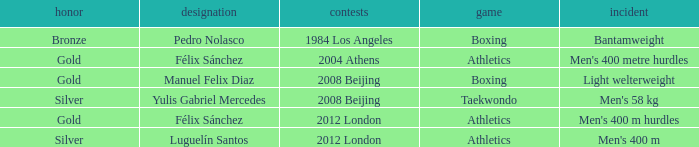Which Medal had a Games of 2008 beijing, and a Sport of taekwondo? Silver. 